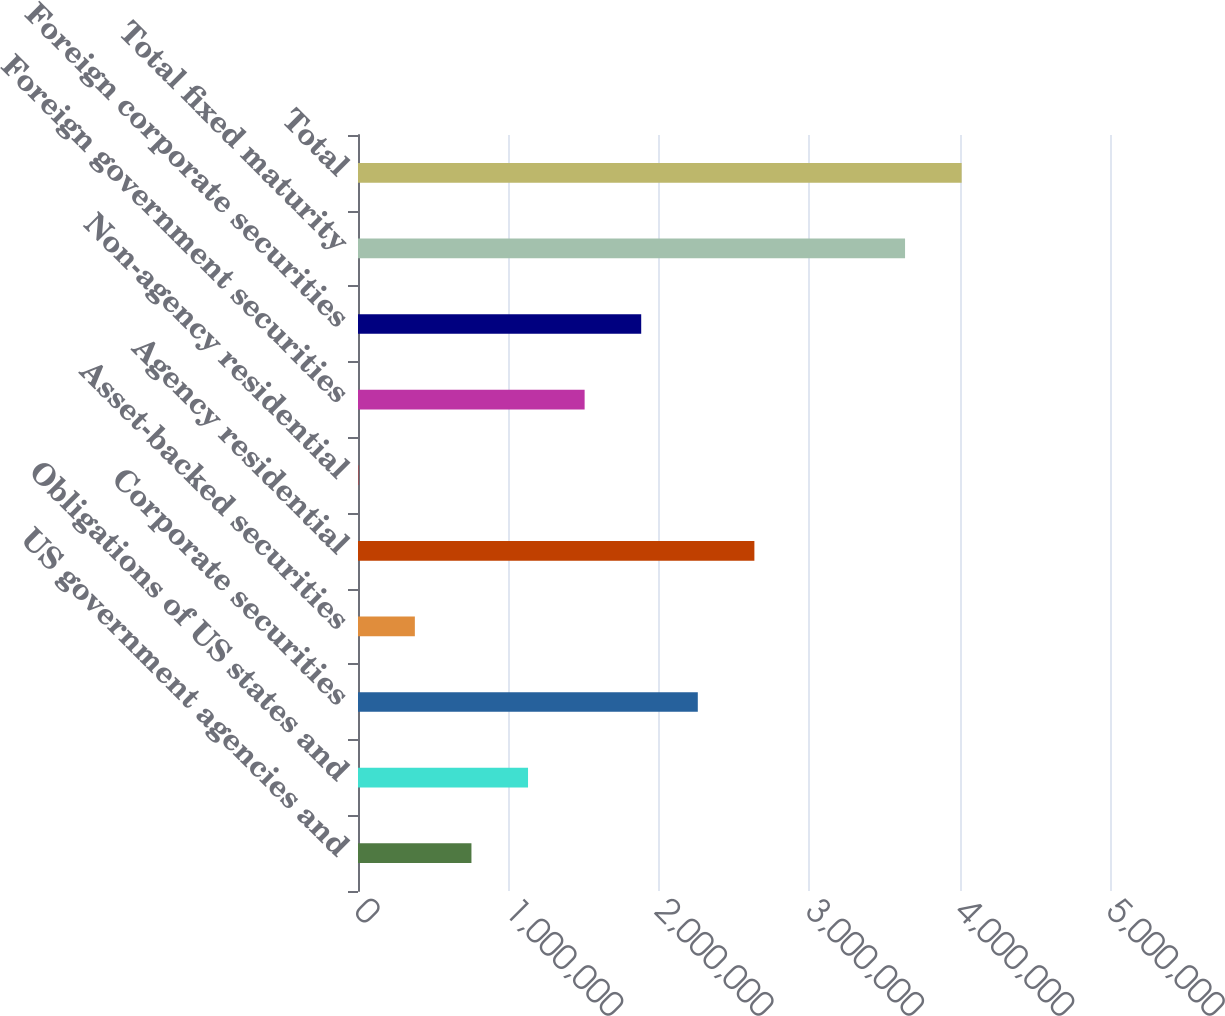Convert chart. <chart><loc_0><loc_0><loc_500><loc_500><bar_chart><fcel>US government agencies and<fcel>Obligations of US states and<fcel>Corporate securities<fcel>Asset-backed securities<fcel>Agency residential<fcel>Non-agency residential<fcel>Foreign government securities<fcel>Foreign corporate securities<fcel>Total fixed maturity<fcel>Total<nl><fcel>754274<fcel>1.13053e+06<fcel>2.25931e+06<fcel>378016<fcel>2.63557e+06<fcel>1758<fcel>1.50679e+06<fcel>1.88305e+06<fcel>3.63731e+06<fcel>4.01357e+06<nl></chart> 